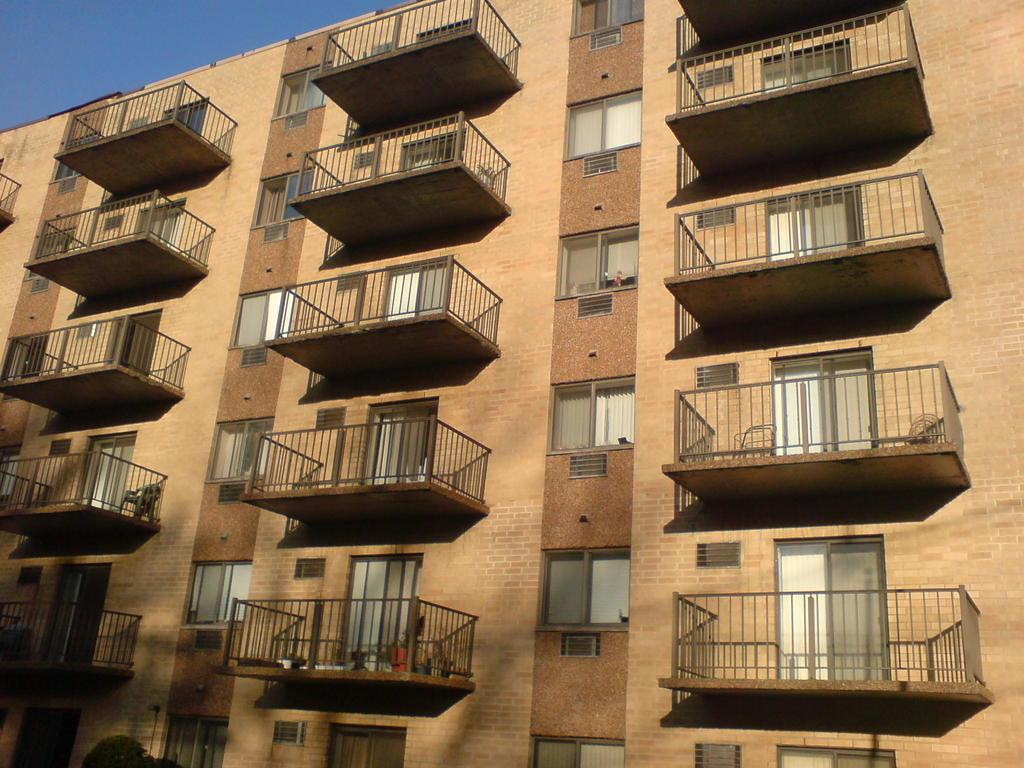What type of structure is present in the image? There is a building in the image. What features can be seen on the building? The building has windows and doors. What type of furniture is visible in the image? There is a chair in the image. What is visible in the background of the image? The sky is visible in the image. What type of holiday is being celebrated in the image? There is no indication of a holiday being celebrated in the image. Where is the stove located in the image? There is no stove present in the image. 